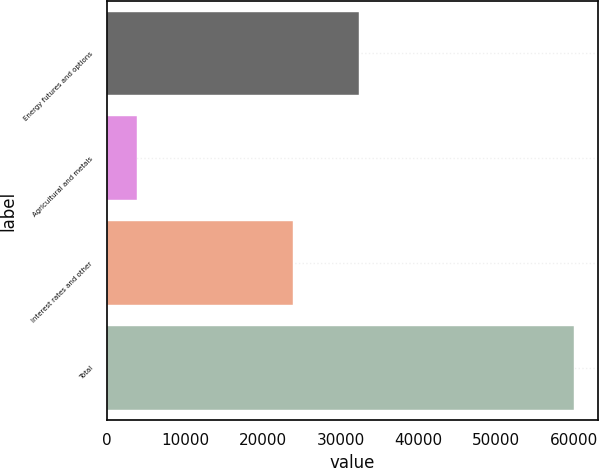<chart> <loc_0><loc_0><loc_500><loc_500><bar_chart><fcel>Energy futures and options<fcel>Agricultural and metals<fcel>Interest rates and other<fcel>Total<nl><fcel>32329<fcel>3878<fcel>23834<fcel>60041<nl></chart> 